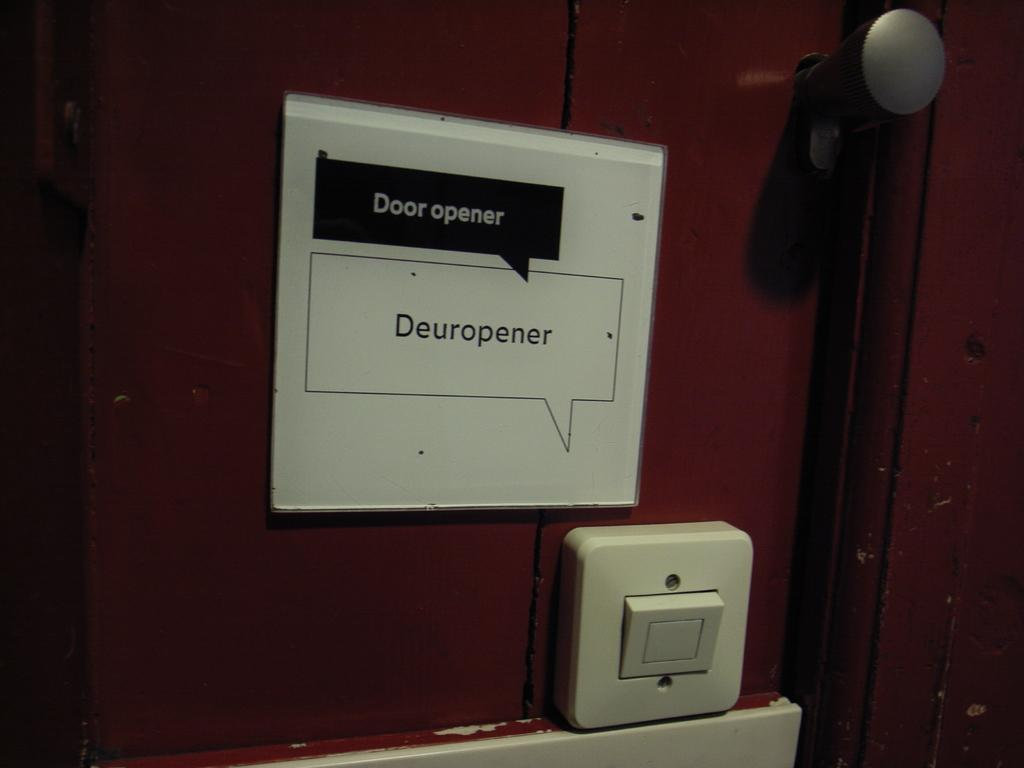<image>
Describe the image concisely. A picture on a wall labeling a switch as a door opener. 